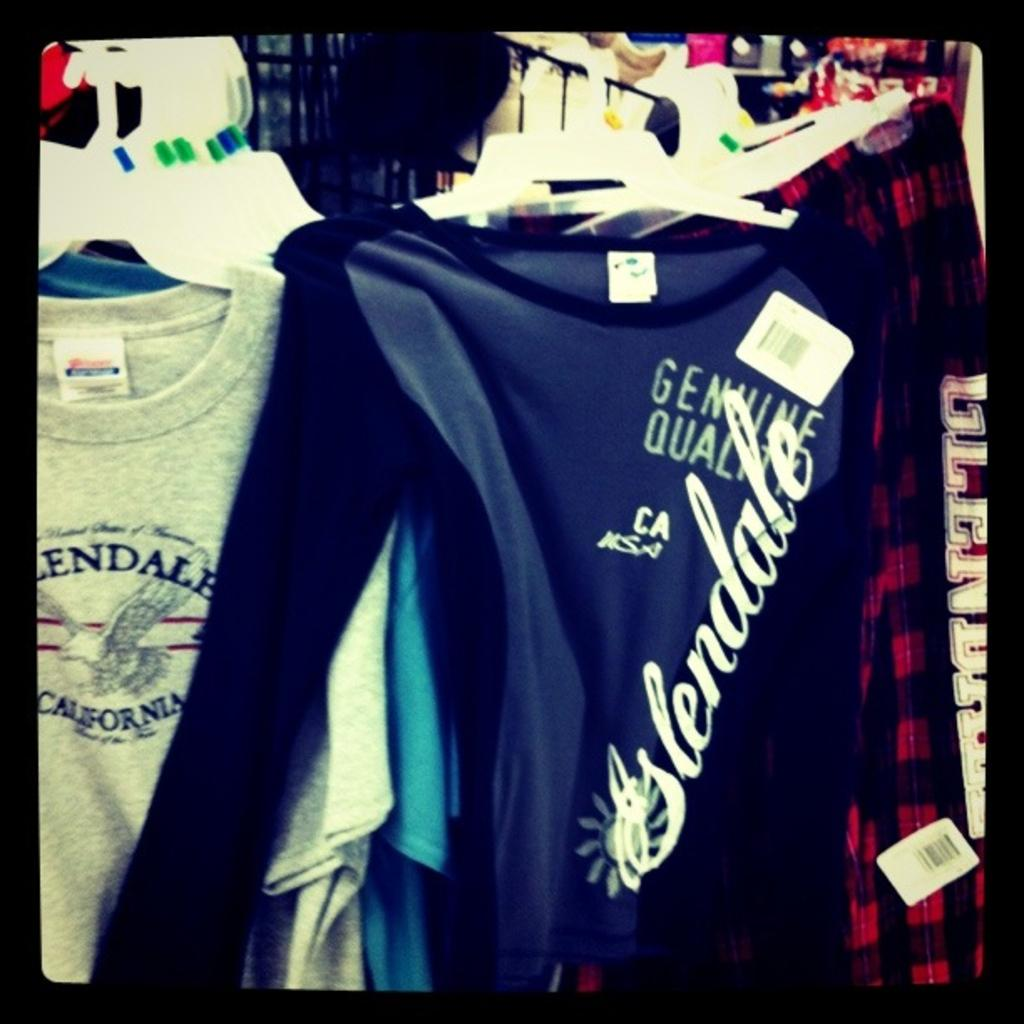Provide a one-sentence caption for the provided image. A blue shirt saying glendale on it is next to a grey shirt also saying glendale on it. 